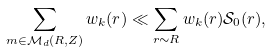<formula> <loc_0><loc_0><loc_500><loc_500>\sum _ { m \in \mathcal { M } _ { d } ( R , Z ) } w _ { k } ( r ) \ll \sum _ { r \sim R } w _ { k } ( r ) \mathcal { S } _ { 0 } ( r ) ,</formula> 